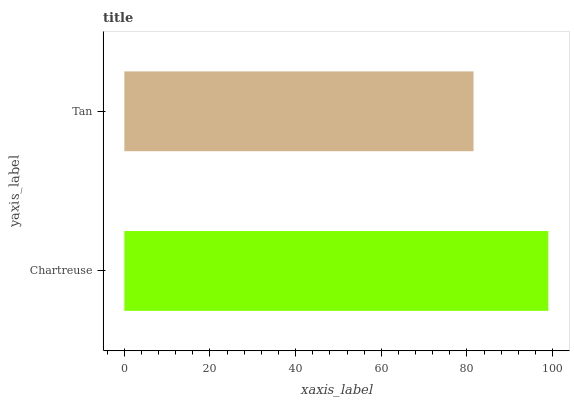Is Tan the minimum?
Answer yes or no. Yes. Is Chartreuse the maximum?
Answer yes or no. Yes. Is Tan the maximum?
Answer yes or no. No. Is Chartreuse greater than Tan?
Answer yes or no. Yes. Is Tan less than Chartreuse?
Answer yes or no. Yes. Is Tan greater than Chartreuse?
Answer yes or no. No. Is Chartreuse less than Tan?
Answer yes or no. No. Is Chartreuse the high median?
Answer yes or no. Yes. Is Tan the low median?
Answer yes or no. Yes. Is Tan the high median?
Answer yes or no. No. Is Chartreuse the low median?
Answer yes or no. No. 